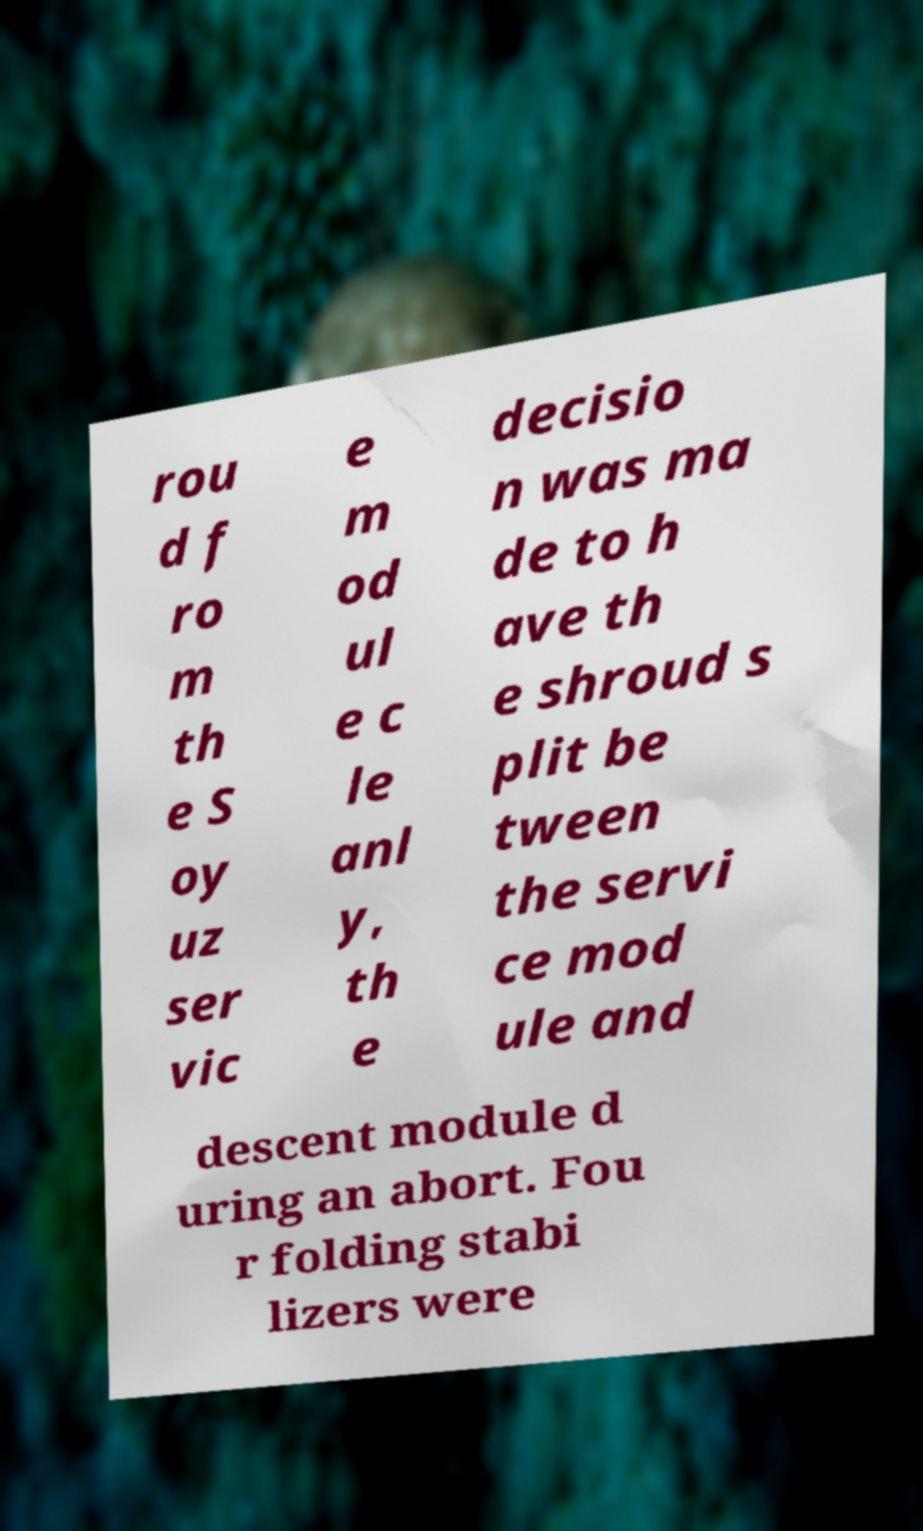There's text embedded in this image that I need extracted. Can you transcribe it verbatim? rou d f ro m th e S oy uz ser vic e m od ul e c le anl y, th e decisio n was ma de to h ave th e shroud s plit be tween the servi ce mod ule and descent module d uring an abort. Fou r folding stabi lizers were 